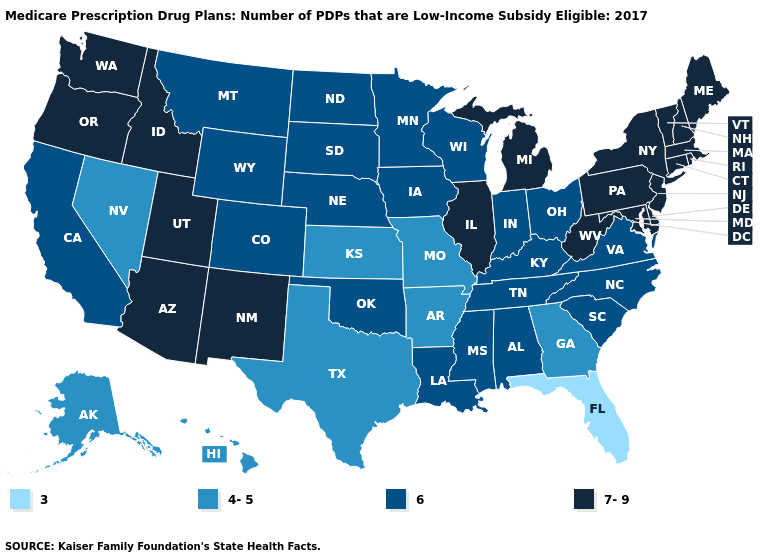Among the states that border Washington , which have the lowest value?
Write a very short answer. Idaho, Oregon. Does Ohio have a lower value than Georgia?
Be succinct. No. What is the lowest value in states that border Alabama?
Give a very brief answer. 3. Among the states that border Kansas , which have the lowest value?
Be succinct. Missouri. What is the lowest value in states that border Wyoming?
Keep it brief. 6. Name the states that have a value in the range 3?
Answer briefly. Florida. What is the value of Colorado?
Give a very brief answer. 6. Does South Carolina have a lower value than Arizona?
Concise answer only. Yes. What is the value of Kentucky?
Answer briefly. 6. Does Illinois have a lower value than Maryland?
Give a very brief answer. No. Name the states that have a value in the range 4-5?
Concise answer only. Alaska, Arkansas, Georgia, Hawaii, Kansas, Missouri, Nevada, Texas. Does the map have missing data?
Short answer required. No. Is the legend a continuous bar?
Keep it brief. No. What is the value of Rhode Island?
Keep it brief. 7-9. 